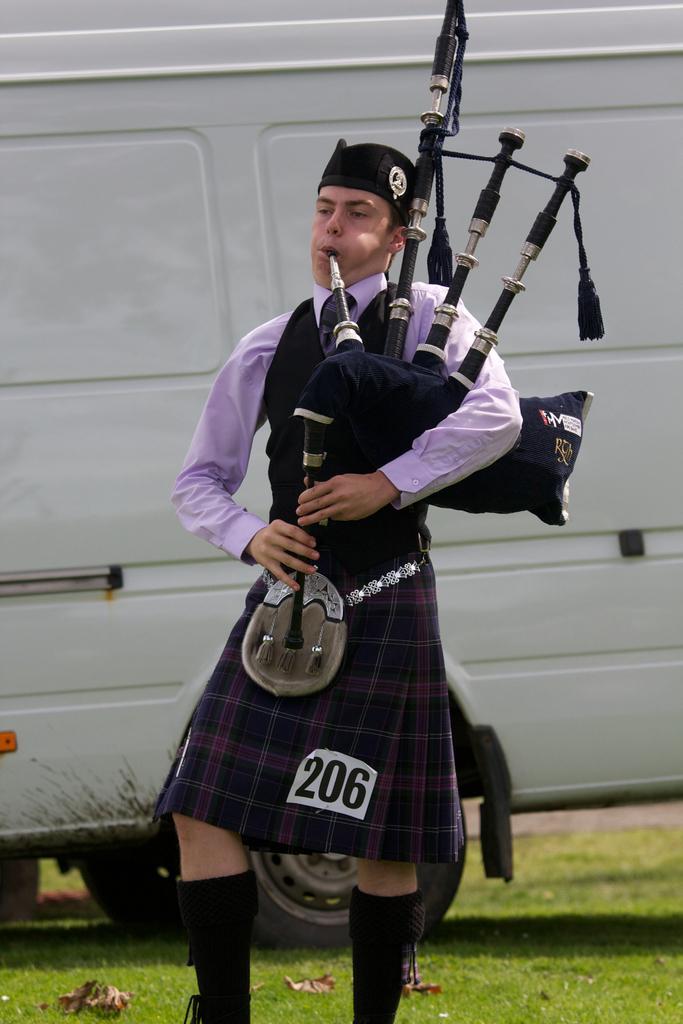How would you summarize this image in a sentence or two? In the center of the image there is a person standing and holding a bag piper. In the background we can see vehicle and grass. 